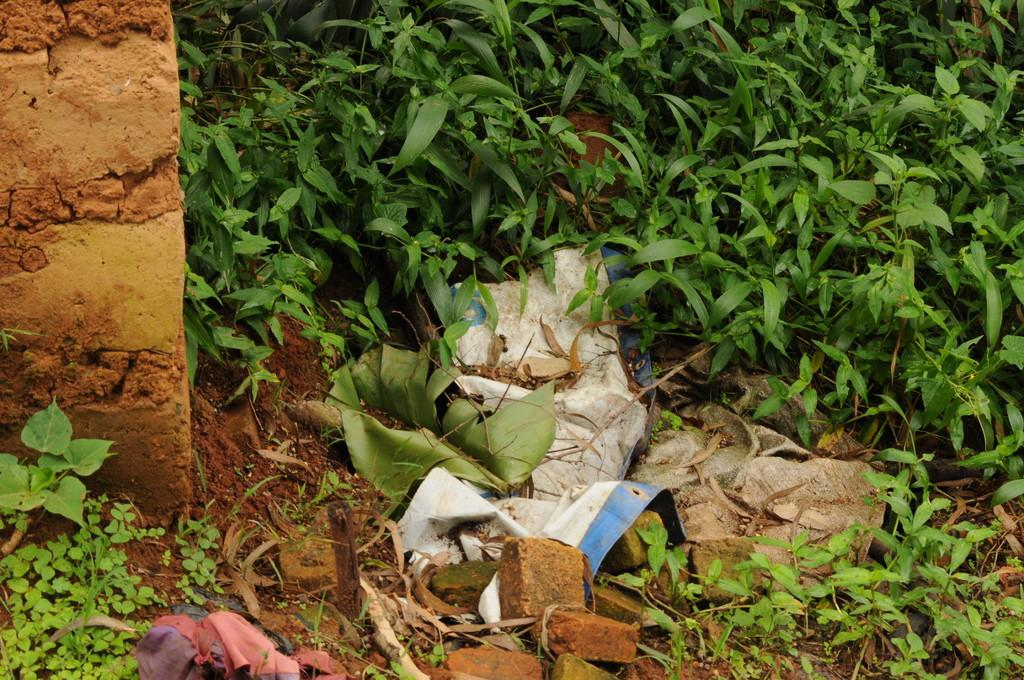What type of structure is on the left side of the image? There is a brick wall on the left side of the image. What can be found on the ground in the image? There are plants and bricks on the ground in the image. Are there any other items on the ground besides plants and bricks? Yes, there are other items on the ground in the image. What type of brass instrument can be heard playing in the image? There is no brass instrument or sound present in the image; it is a still image. 